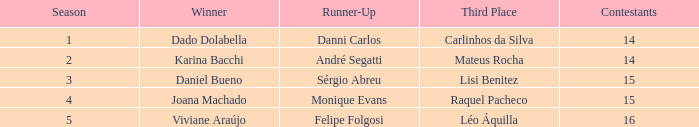How many contestants were there when the runner-up was Monique Evans? 15.0. 